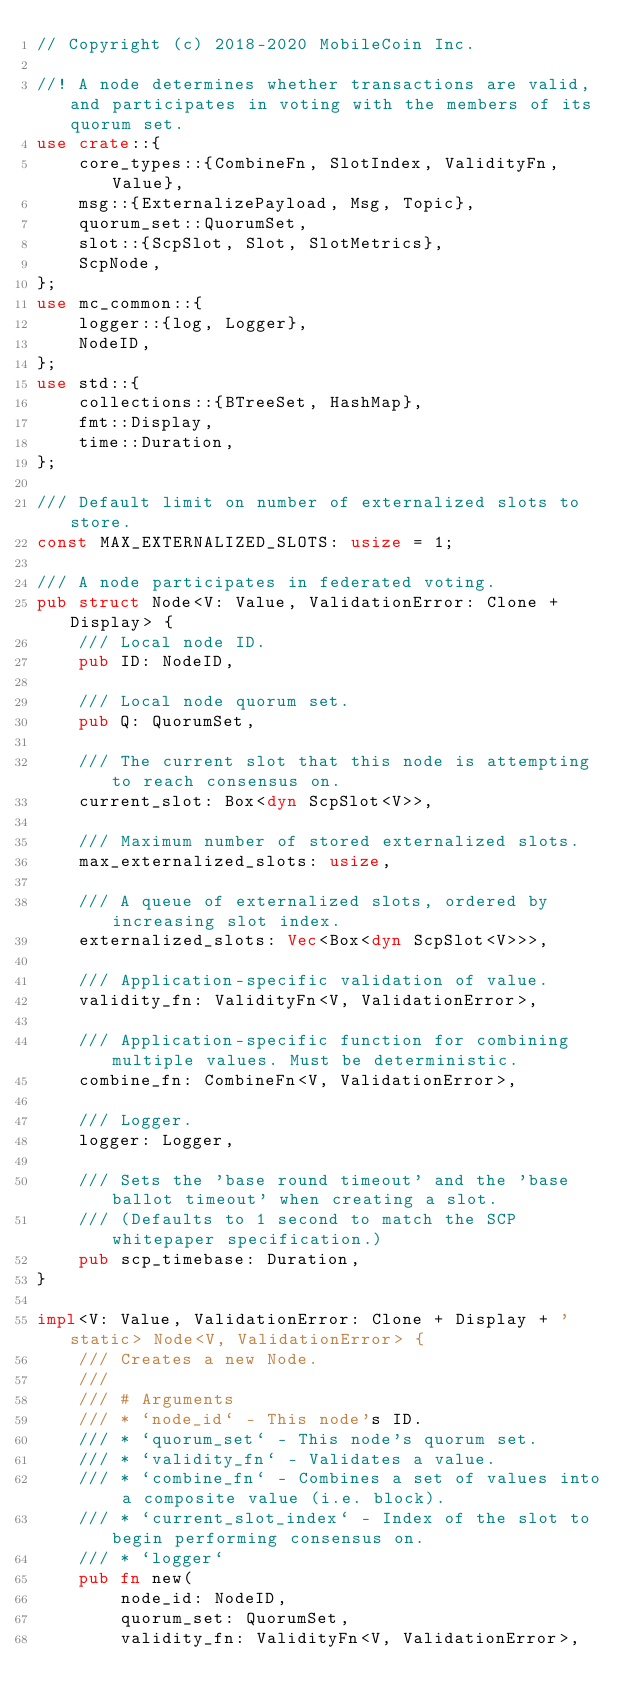Convert code to text. <code><loc_0><loc_0><loc_500><loc_500><_Rust_>// Copyright (c) 2018-2020 MobileCoin Inc.

//! A node determines whether transactions are valid, and participates in voting with the members of its quorum set.
use crate::{
    core_types::{CombineFn, SlotIndex, ValidityFn, Value},
    msg::{ExternalizePayload, Msg, Topic},
    quorum_set::QuorumSet,
    slot::{ScpSlot, Slot, SlotMetrics},
    ScpNode,
};
use mc_common::{
    logger::{log, Logger},
    NodeID,
};
use std::{
    collections::{BTreeSet, HashMap},
    fmt::Display,
    time::Duration,
};

/// Default limit on number of externalized slots to store.
const MAX_EXTERNALIZED_SLOTS: usize = 1;

/// A node participates in federated voting.
pub struct Node<V: Value, ValidationError: Clone + Display> {
    /// Local node ID.
    pub ID: NodeID,

    /// Local node quorum set.
    pub Q: QuorumSet,

    /// The current slot that this node is attempting to reach consensus on.
    current_slot: Box<dyn ScpSlot<V>>,

    /// Maximum number of stored externalized slots.
    max_externalized_slots: usize,

    /// A queue of externalized slots, ordered by increasing slot index.
    externalized_slots: Vec<Box<dyn ScpSlot<V>>>,

    /// Application-specific validation of value.
    validity_fn: ValidityFn<V, ValidationError>,

    /// Application-specific function for combining multiple values. Must be deterministic.
    combine_fn: CombineFn<V, ValidationError>,

    /// Logger.
    logger: Logger,

    /// Sets the 'base round timeout' and the 'base ballot timeout' when creating a slot.
    /// (Defaults to 1 second to match the SCP whitepaper specification.)
    pub scp_timebase: Duration,
}

impl<V: Value, ValidationError: Clone + Display + 'static> Node<V, ValidationError> {
    /// Creates a new Node.
    ///
    /// # Arguments
    /// * `node_id` - This node's ID.
    /// * `quorum_set` - This node's quorum set.
    /// * `validity_fn` - Validates a value.
    /// * `combine_fn` - Combines a set of values into a composite value (i.e. block).
    /// * `current_slot_index` - Index of the slot to begin performing consensus on.
    /// * `logger`
    pub fn new(
        node_id: NodeID,
        quorum_set: QuorumSet,
        validity_fn: ValidityFn<V, ValidationError>,</code> 